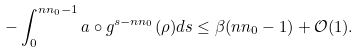Convert formula to latex. <formula><loc_0><loc_0><loc_500><loc_500>- \int _ { 0 } ^ { n n _ { 0 } - 1 } a \circ g ^ { s - n n _ { 0 } } ( \rho ) d s \leq \beta ( n n _ { 0 } - 1 ) + \mathcal { O } ( 1 ) .</formula> 